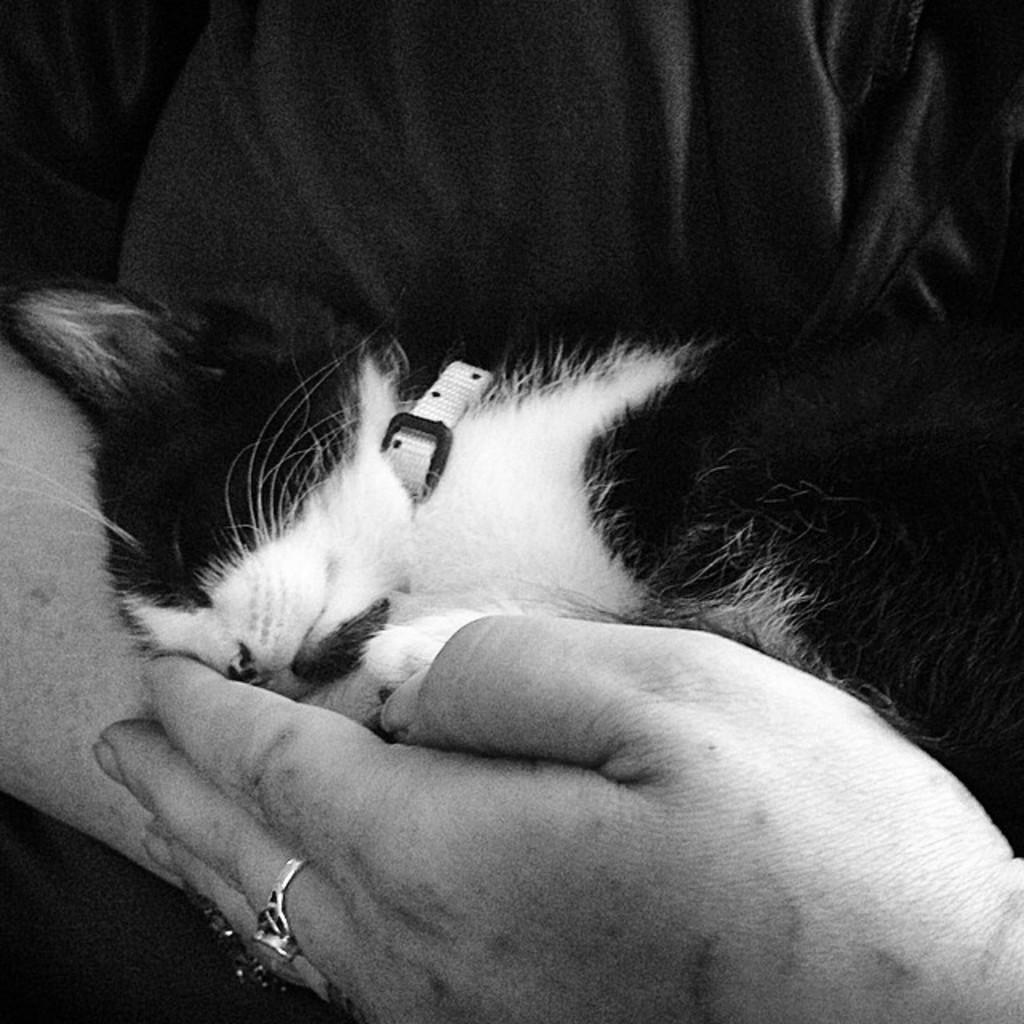Could you give a brief overview of what you see in this image? In this image, we can see a person holding a kitten. 